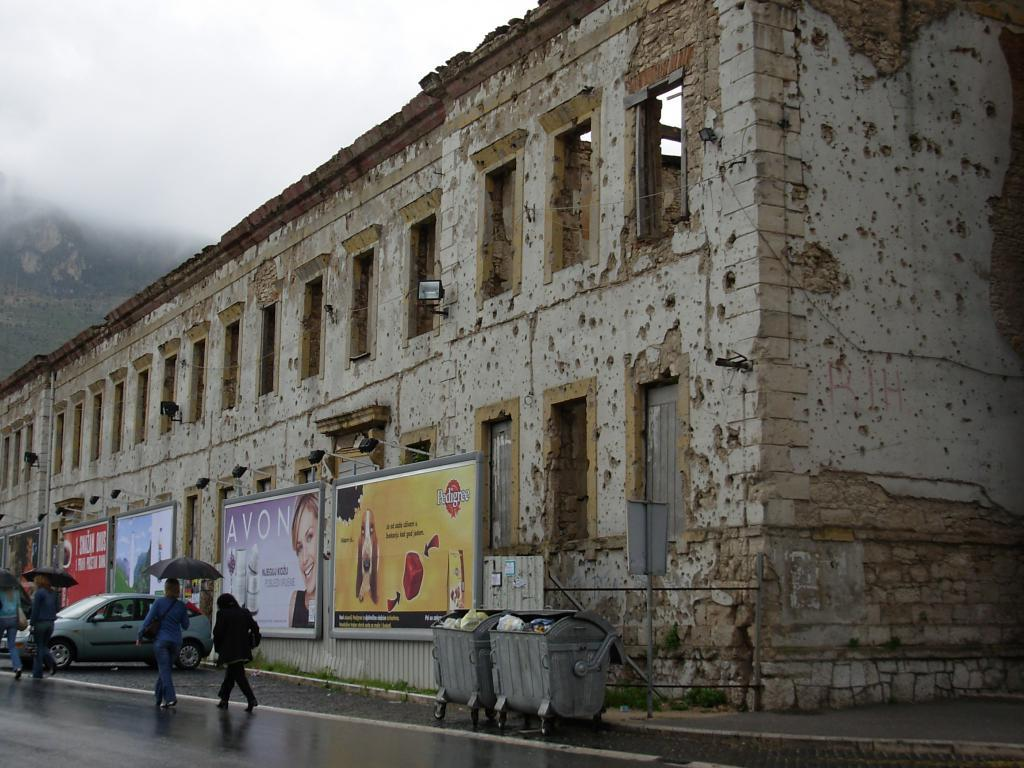<image>
Give a short and clear explanation of the subsequent image. The outside of an old building with a Avon banner on it 